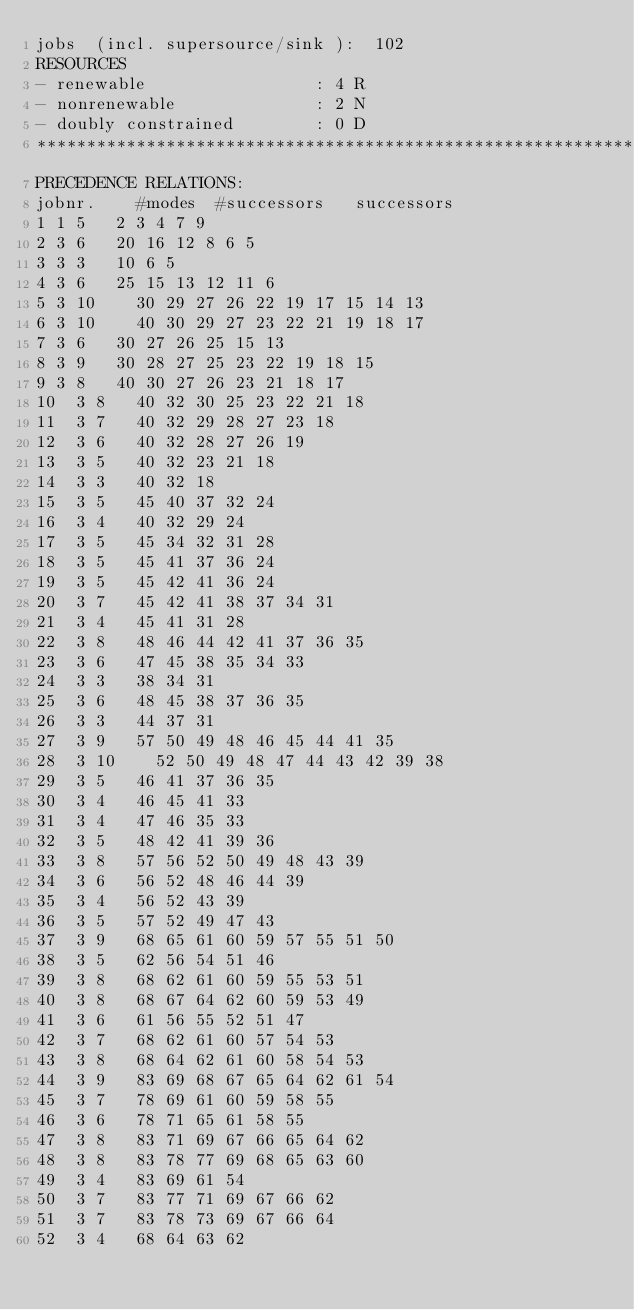<code> <loc_0><loc_0><loc_500><loc_500><_ObjectiveC_>jobs  (incl. supersource/sink ):	102
RESOURCES
- renewable                 : 4 R
- nonrenewable              : 2 N
- doubly constrained        : 0 D
************************************************************************
PRECEDENCE RELATIONS:
jobnr.    #modes  #successors   successors
1	1	5		2 3 4 7 9 
2	3	6		20 16 12 8 6 5 
3	3	3		10 6 5 
4	3	6		25 15 13 12 11 6 
5	3	10		30 29 27 26 22 19 17 15 14 13 
6	3	10		40 30 29 27 23 22 21 19 18 17 
7	3	6		30 27 26 25 15 13 
8	3	9		30 28 27 25 23 22 19 18 15 
9	3	8		40 30 27 26 23 21 18 17 
10	3	8		40 32 30 25 23 22 21 18 
11	3	7		40 32 29 28 27 23 18 
12	3	6		40 32 28 27 26 19 
13	3	5		40 32 23 21 18 
14	3	3		40 32 18 
15	3	5		45 40 37 32 24 
16	3	4		40 32 29 24 
17	3	5		45 34 32 31 28 
18	3	5		45 41 37 36 24 
19	3	5		45 42 41 36 24 
20	3	7		45 42 41 38 37 34 31 
21	3	4		45 41 31 28 
22	3	8		48 46 44 42 41 37 36 35 
23	3	6		47 45 38 35 34 33 
24	3	3		38 34 31 
25	3	6		48 45 38 37 36 35 
26	3	3		44 37 31 
27	3	9		57 50 49 48 46 45 44 41 35 
28	3	10		52 50 49 48 47 44 43 42 39 38 
29	3	5		46 41 37 36 35 
30	3	4		46 45 41 33 
31	3	4		47 46 35 33 
32	3	5		48 42 41 39 36 
33	3	8		57 56 52 50 49 48 43 39 
34	3	6		56 52 48 46 44 39 
35	3	4		56 52 43 39 
36	3	5		57 52 49 47 43 
37	3	9		68 65 61 60 59 57 55 51 50 
38	3	5		62 56 54 51 46 
39	3	8		68 62 61 60 59 55 53 51 
40	3	8		68 67 64 62 60 59 53 49 
41	3	6		61 56 55 52 51 47 
42	3	7		68 62 61 60 57 54 53 
43	3	8		68 64 62 61 60 58 54 53 
44	3	9		83 69 68 67 65 64 62 61 54 
45	3	7		78 69 61 60 59 58 55 
46	3	6		78 71 65 61 58 55 
47	3	8		83 71 69 67 66 65 64 62 
48	3	8		83 78 77 69 68 65 63 60 
49	3	4		83 69 61 54 
50	3	7		83 77 71 69 67 66 62 
51	3	7		83 78 73 69 67 66 64 
52	3	4		68 64 63 62 </code> 